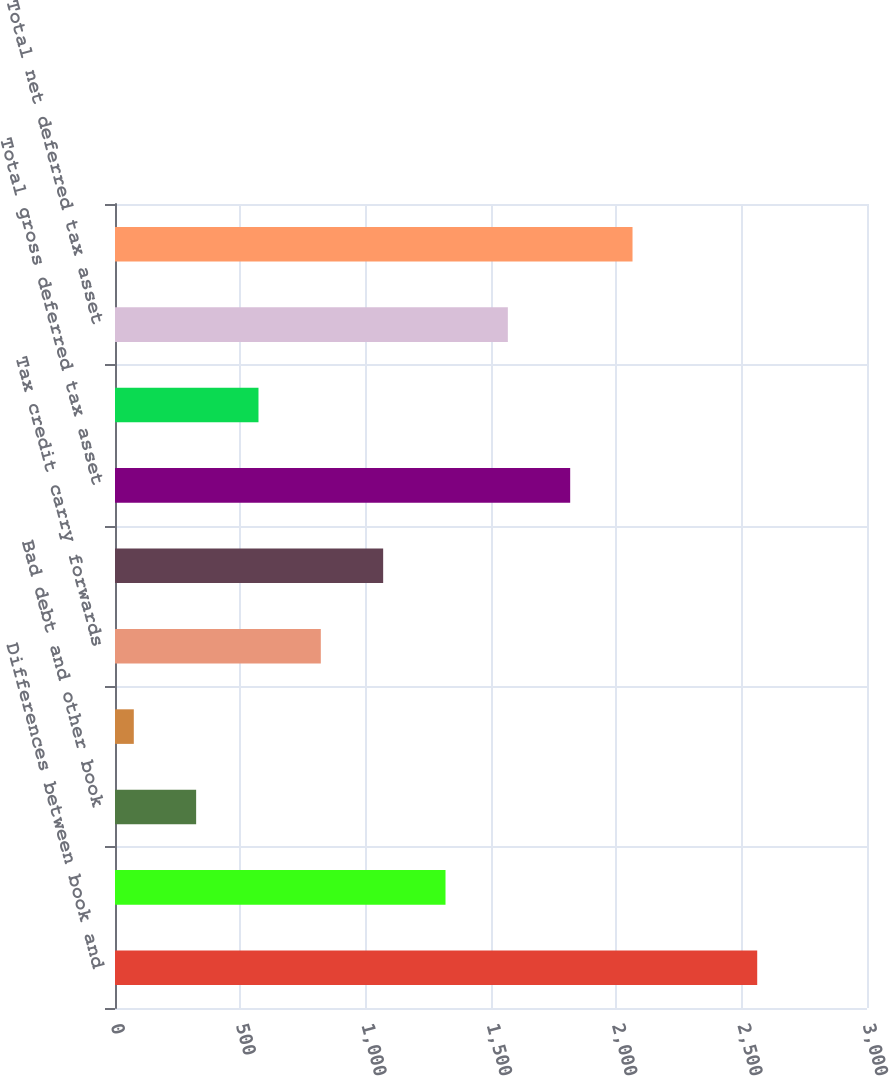Convert chart to OTSL. <chart><loc_0><loc_0><loc_500><loc_500><bar_chart><fcel>Differences between book and<fcel>Operating loss carry forwards<fcel>Bad debt and other book<fcel>Retirement costs<fcel>Tax credit carry forwards<fcel>Other deductible temporary<fcel>Total gross deferred tax asset<fcel>Less Valuation allowance<fcel>Total net deferred tax asset<fcel>Net deferred tax liability<nl><fcel>2562<fcel>1318.5<fcel>323.7<fcel>75<fcel>821.1<fcel>1069.8<fcel>1815.9<fcel>572.4<fcel>1567.2<fcel>2064.6<nl></chart> 